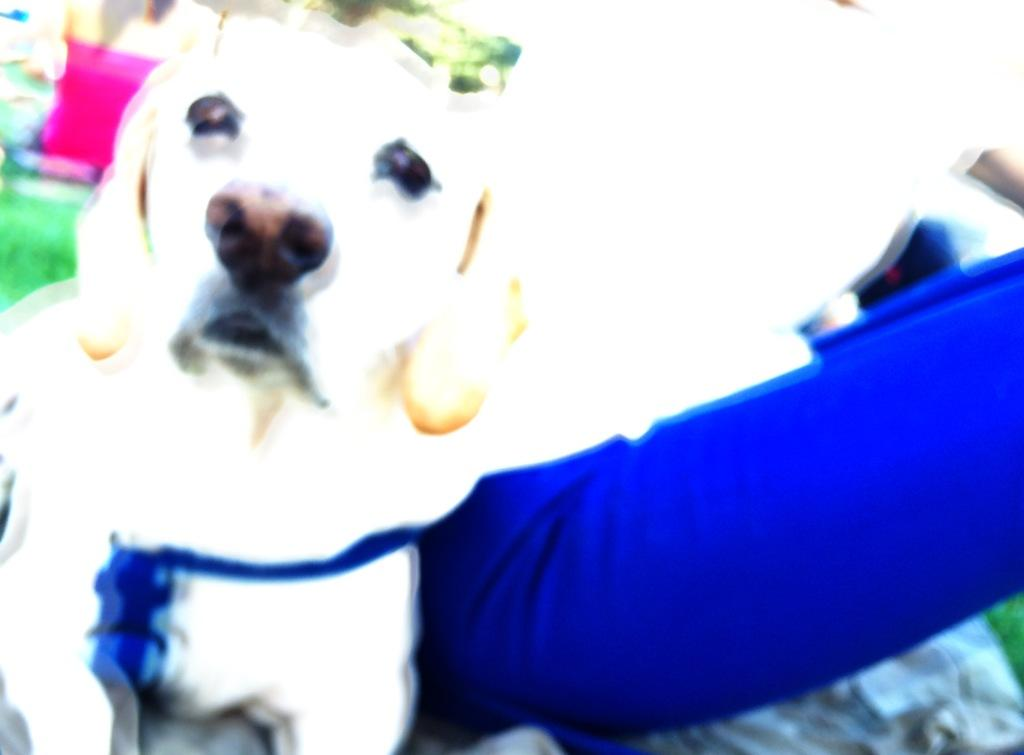What type of animal is present in the image? There is a dog in the image. What is the surface beneath the dog? There is grass at the bottom of the image. Who is the dog's aunt in the image? There is no mention of an aunt or any human family members in the image, as it only features a dog and grass. 